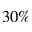<formula> <loc_0><loc_0><loc_500><loc_500>3 0 \%</formula> 